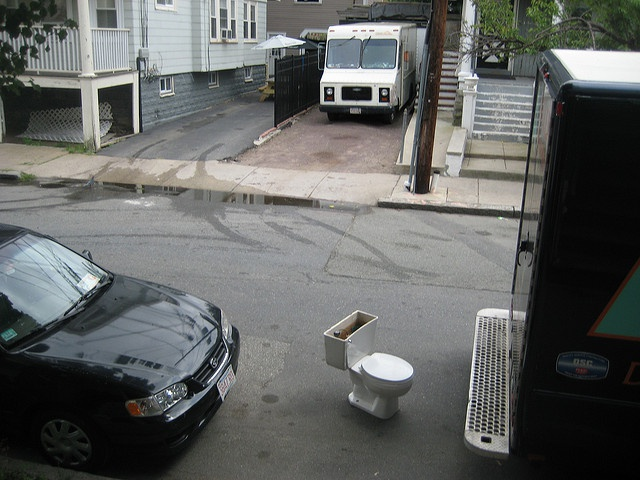Describe the objects in this image and their specific colors. I can see truck in black, gray, white, and darkgray tones, car in black, gray, and darkgray tones, truck in black, white, gray, and darkgray tones, and toilet in black, gray, lightgray, and darkgray tones in this image. 